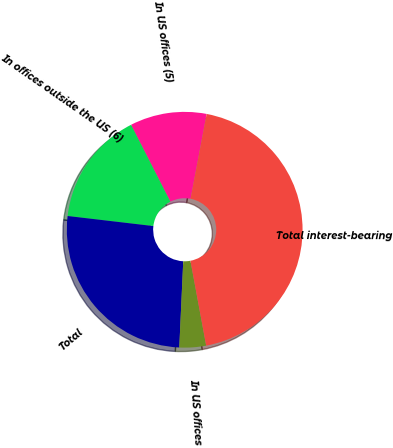<chart> <loc_0><loc_0><loc_500><loc_500><pie_chart><fcel>In US offices (5)<fcel>In offices outside the US (6)<fcel>Total<fcel>In US offices<fcel>Total interest-bearing<nl><fcel>10.5%<fcel>15.62%<fcel>26.13%<fcel>3.65%<fcel>44.1%<nl></chart> 